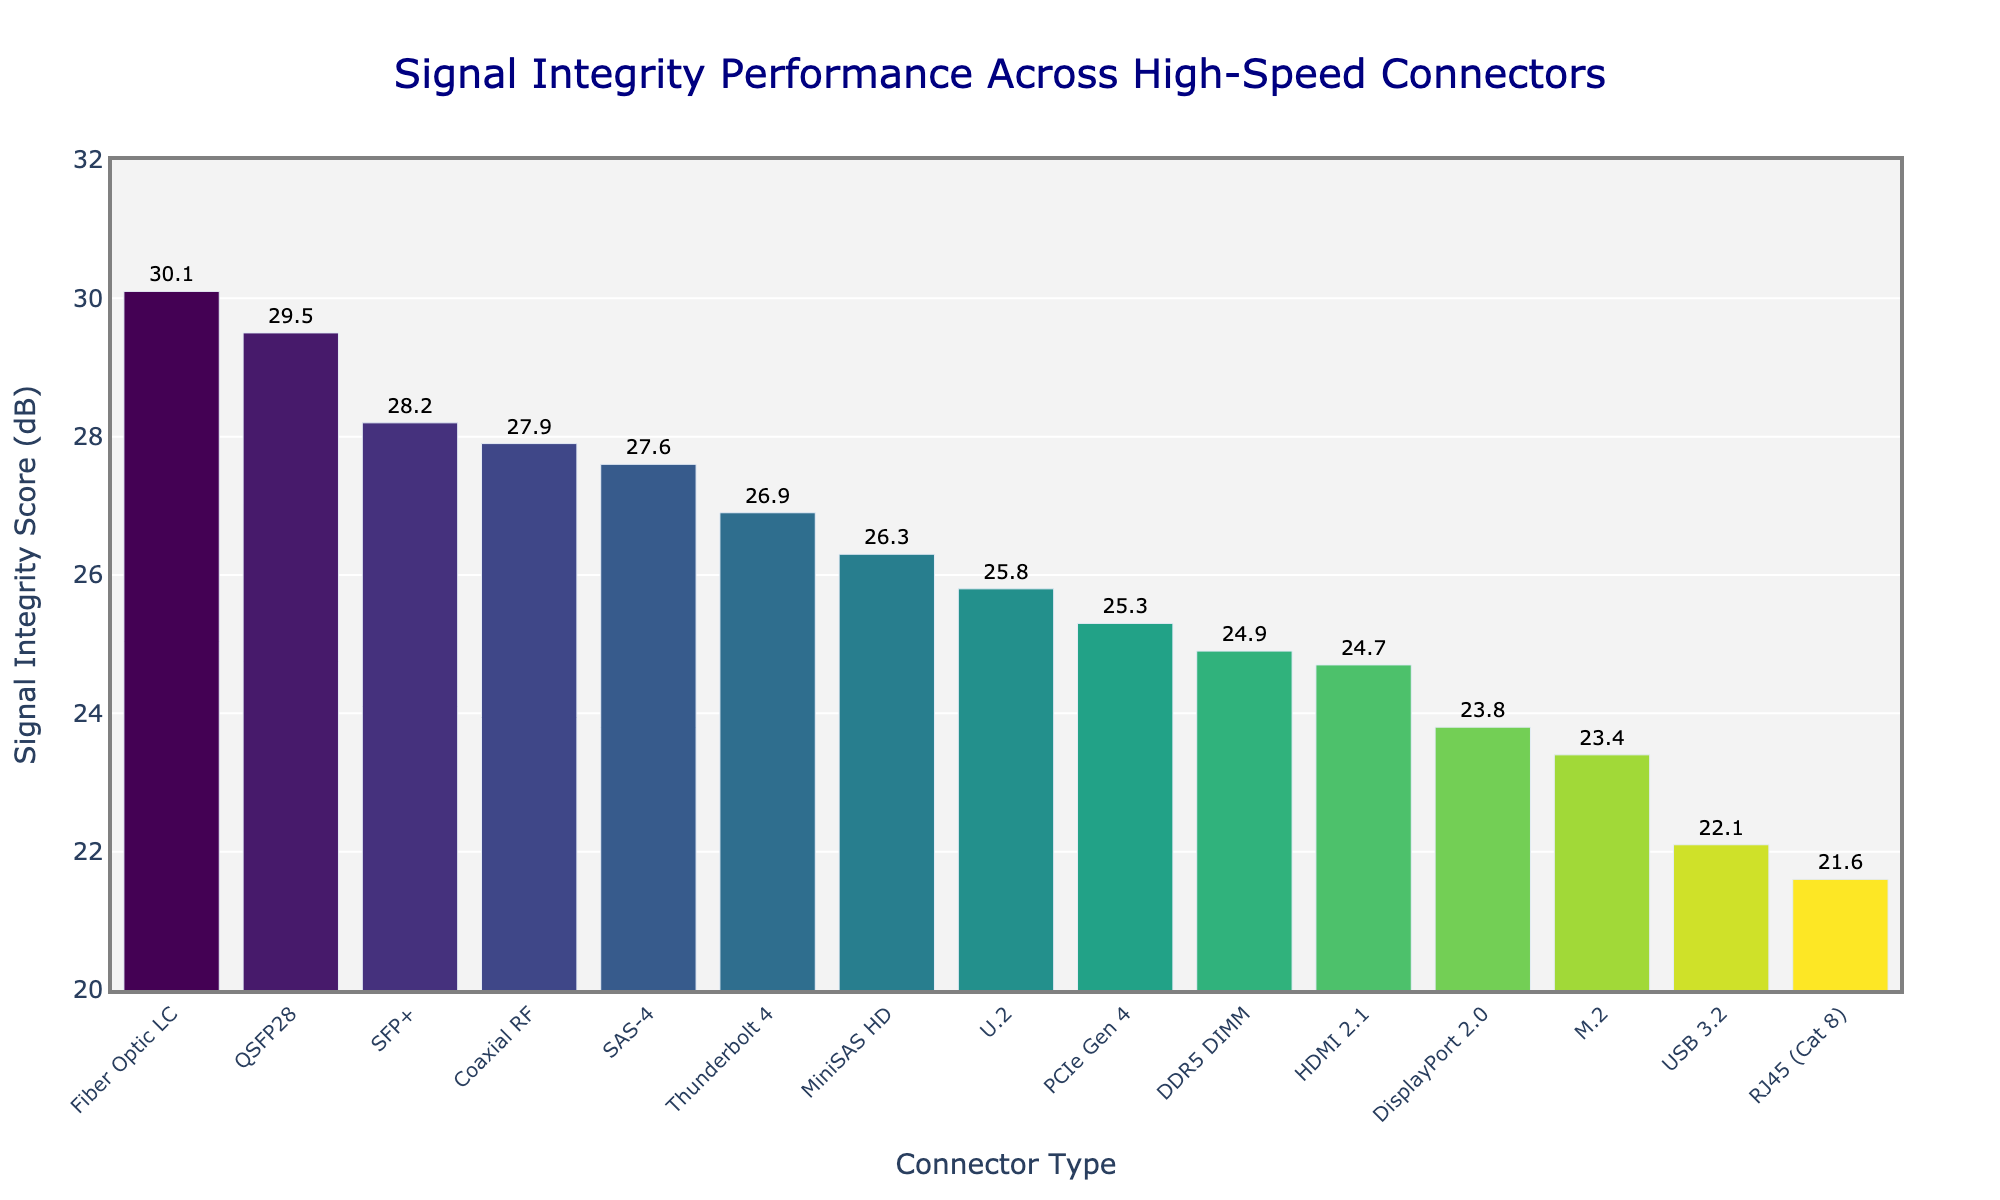Which connector type has the highest Signal Integrity Score? To determine the connector type with the highest Signal Integrity Score, look at the tallest bar in the chart. Identify the connector type corresponding to this bar.
Answer: Fiber Optic LC What is the Signal Integrity Score difference between RJ45 (Cat 8) and PCIe Gen 4? Locate the bars for RJ45 (Cat 8) and PCIe Gen 4. The Signal Integrity Score for RJ45 (Cat 8) is 21.6 dB, and for PCIe Gen 4, it is 25.3 dB. Subtract the smaller value from the larger value: 25.3 - 21.6.
Answer: 3.7 dB Which two connector types have the closest Signal Integrity Scores? Inspect the height and values of the bars and find the two bars with the smallest difference in height/values. DDR5 DIMM and HDMI 2.1 have scores 24.9 dB and 24.7 dB respectively. The difference is 0.2 dB, the smallest.
Answer: DDR5 DIMM and HDMI 2.1 What is the average Signal Integrity Score of the top three performing connectors? First, identify the top three performing connectors: Fiber Optic LC (30.1 dB), QSFP28 (29.5 dB), and SFP+ (28.2 dB). Add their scores and divide by 3: (30.1 + 29.5 + 28.2) / 3.
Answer: 29.27 dB Which connector type is ranked fourth in terms of Signal Integrity Score? Rank the connector types from highest to lowest Signal Integrity Score. The fourth-highest is SAS-4 with a score of 27.6 dB.
Answer: SAS-4 Are there more connectors with Signal Integrity Scores above or below 25 dB? Count the number of bars above 25 dB and those below 25 dB. Above 25 dB: PCIe Gen 4, Thunderbolt 4, SFP+, QSFP28, SAS-4, U.2, MiniSAS HD, Fiber Optic LC, Coaxial RF (9 connectors). Below 25 dB: USB 3.2, HDMI 2.1, DisplayPort 2.0, DDR5 DIMM, M.2, RJ45 (Cat 8) (6 connectors).
Answer: Above What is the median Signal Integrity Score? To find the median, first, list all scores in ascending order. With 15 scores, the middle score is the 8th one: 21.6, 22.1, 23.4, 23.8, 24.7, 24.9, 25.3, **25.8**, 26.3, 26.9, 27.6, 27.9, 28.2, 29.5, 30.1. The 8th score is 25.8 dB.
Answer: 25.8 dB What is the color of the bar representing the Thunderbolt 4 connector? Identify the bar for Thunderbolt 4 and describe its color based on the color scale used in the chart. Assuming a "Viridis" color scheme, the bar would appear as a shade of green.
Answer: Green Is the Signal Integrity Score for M.2 above or below the average of all connector types? Calculate the average Signal Integrity Score for all connector types: (25.3 + 22.1 + 24.7 + 26.9 + 28.2 + 29.5 + 23.8 + 27.6 + 24.9 + 23.4 + 25.8 + 26.3 + 21.6 + 30.1 + 27.9) / 15 = 25.74 dB. M.2 has a score of 23.4 dB, which is below the average.
Answer: Below 